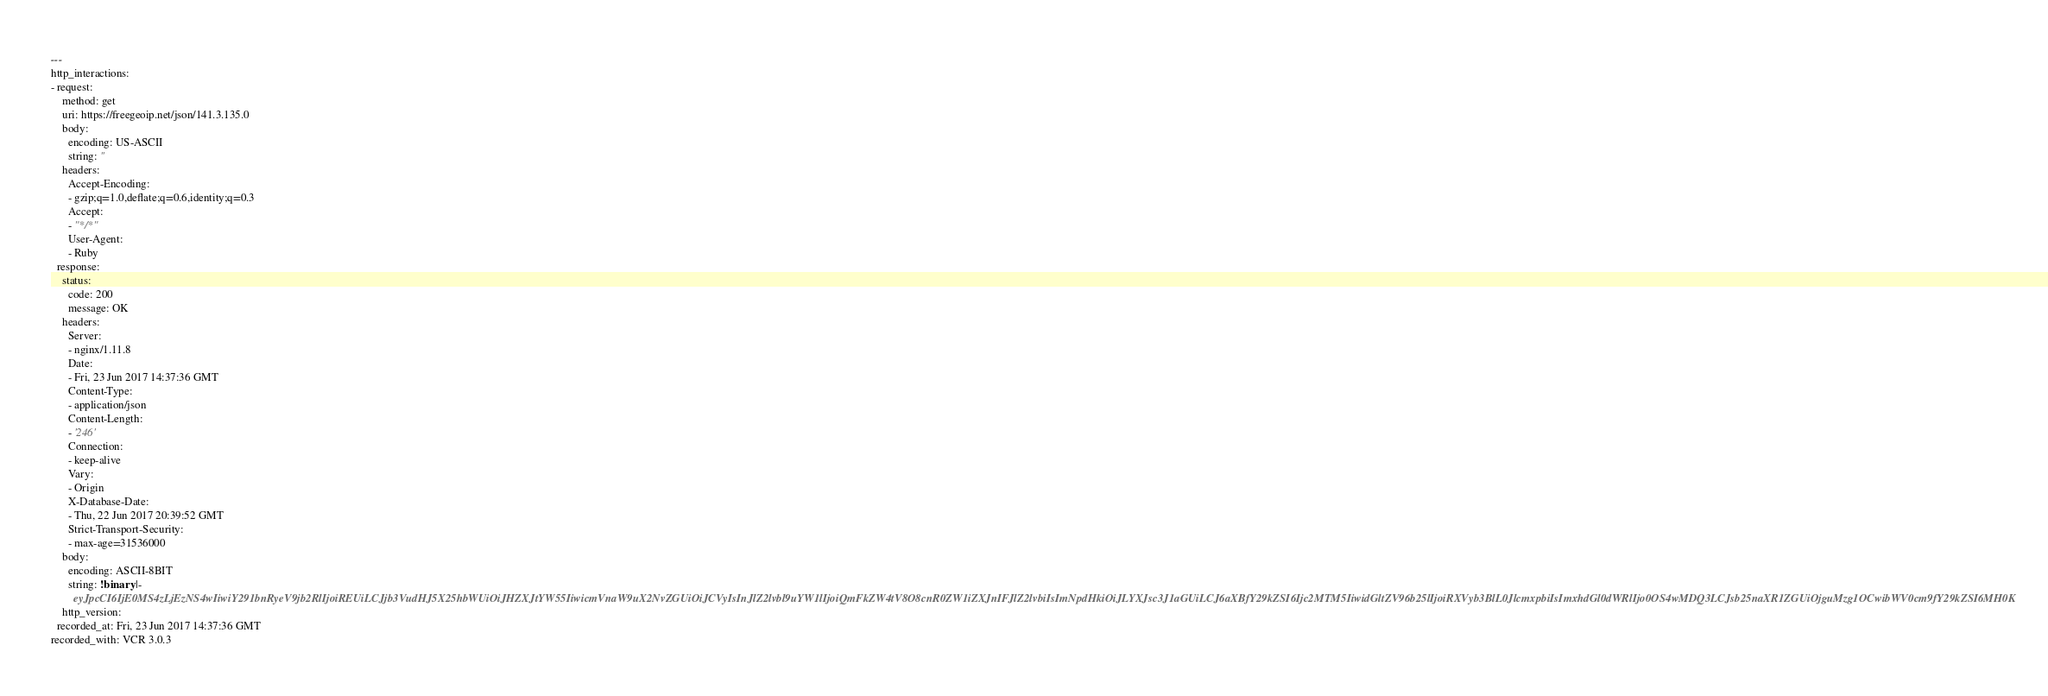Convert code to text. <code><loc_0><loc_0><loc_500><loc_500><_YAML_>---
http_interactions:
- request:
    method: get
    uri: https://freegeoip.net/json/141.3.135.0
    body:
      encoding: US-ASCII
      string: ''
    headers:
      Accept-Encoding:
      - gzip;q=1.0,deflate;q=0.6,identity;q=0.3
      Accept:
      - "*/*"
      User-Agent:
      - Ruby
  response:
    status:
      code: 200
      message: OK
    headers:
      Server:
      - nginx/1.11.8
      Date:
      - Fri, 23 Jun 2017 14:37:36 GMT
      Content-Type:
      - application/json
      Content-Length:
      - '246'
      Connection:
      - keep-alive
      Vary:
      - Origin
      X-Database-Date:
      - Thu, 22 Jun 2017 20:39:52 GMT
      Strict-Transport-Security:
      - max-age=31536000
    body:
      encoding: ASCII-8BIT
      string: !binary |-
        eyJpcCI6IjE0MS4zLjEzNS4wIiwiY291bnRyeV9jb2RlIjoiREUiLCJjb3VudHJ5X25hbWUiOiJHZXJtYW55IiwicmVnaW9uX2NvZGUiOiJCVyIsInJlZ2lvbl9uYW1lIjoiQmFkZW4tV8O8cnR0ZW1iZXJnIFJlZ2lvbiIsImNpdHkiOiJLYXJsc3J1aGUiLCJ6aXBfY29kZSI6Ijc2MTM5IiwidGltZV96b25lIjoiRXVyb3BlL0JlcmxpbiIsImxhdGl0dWRlIjo0OS4wMDQ3LCJsb25naXR1ZGUiOjguMzg1OCwibWV0cm9fY29kZSI6MH0K
    http_version: 
  recorded_at: Fri, 23 Jun 2017 14:37:36 GMT
recorded_with: VCR 3.0.3
</code> 